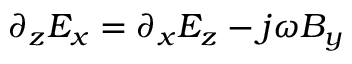<formula> <loc_0><loc_0><loc_500><loc_500>\partial _ { z } E _ { x } = \partial _ { x } E _ { z } - j \omega B _ { y }</formula> 